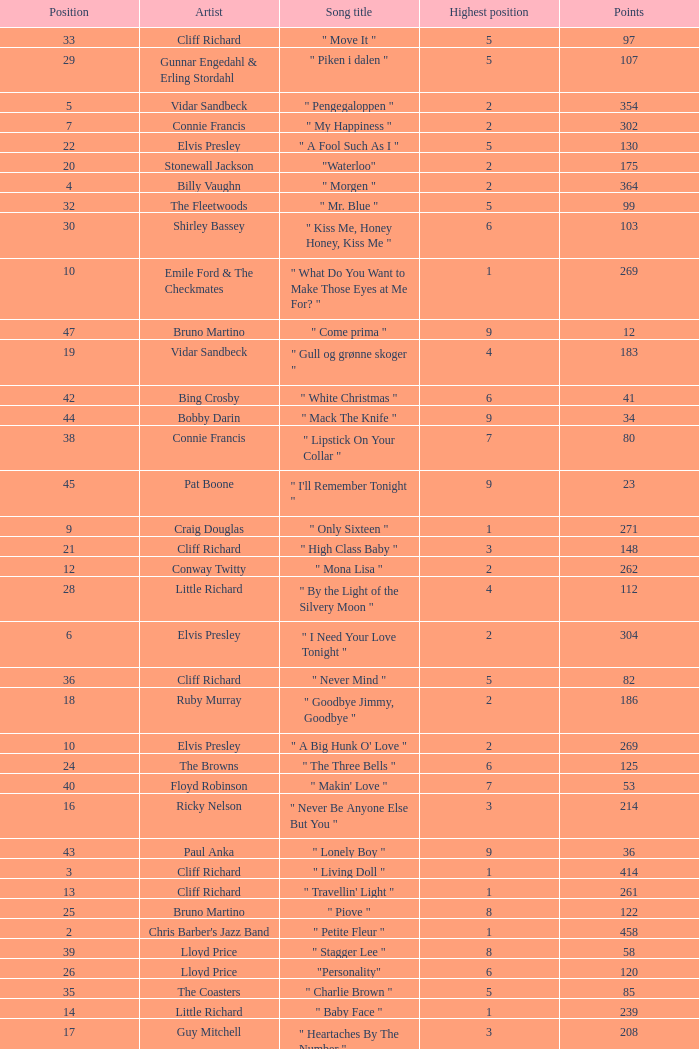What is the nme of the song performed by billy vaughn? " Morgen ". 